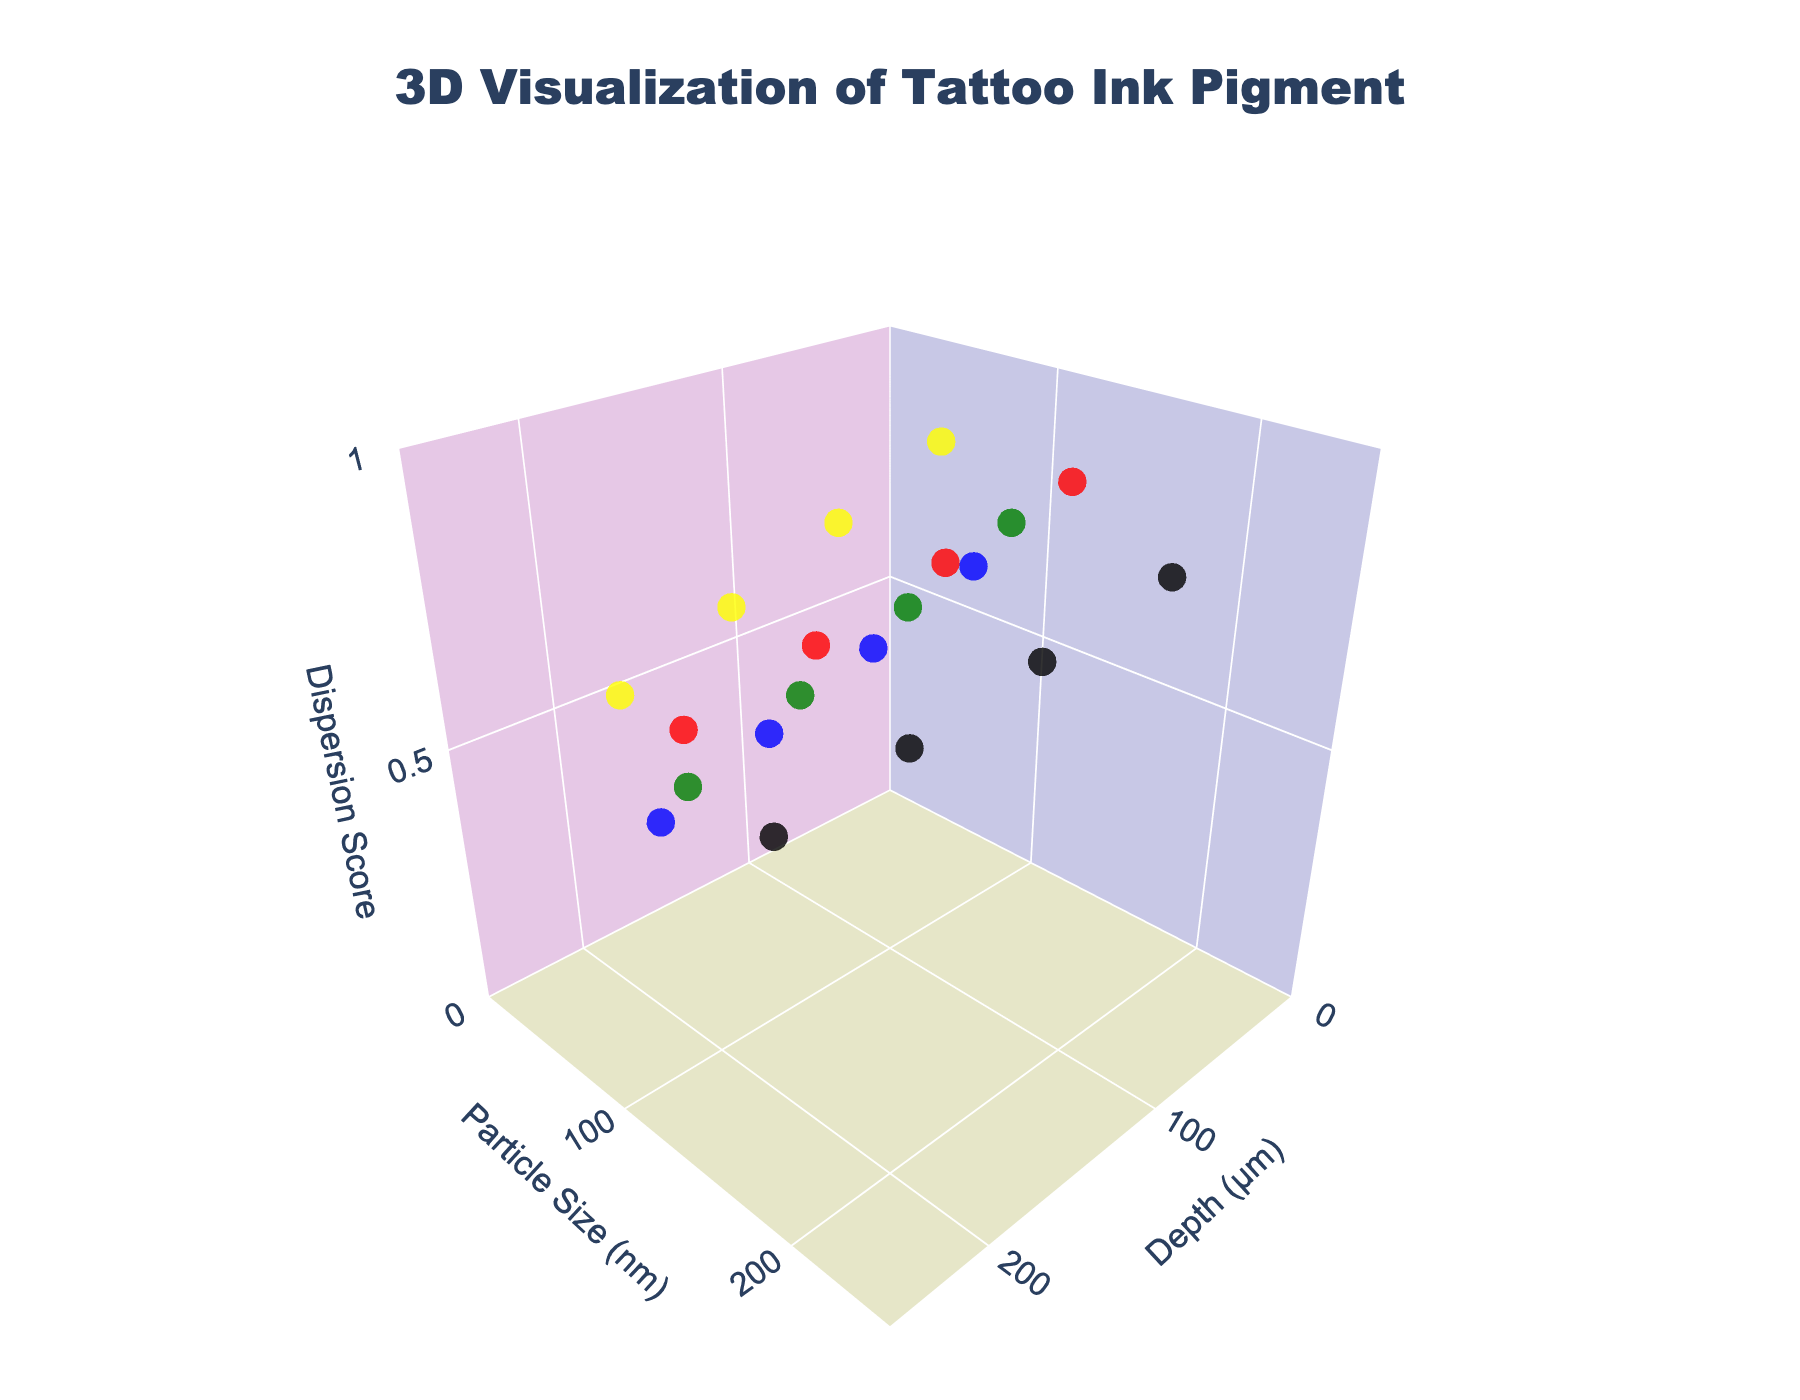What's the title of the figure? The title can be found at the top of the figure. It typically provides an overview of what the figure represents.
Answer: 3D Visualization of Tattoo Ink Pigment What are the labels for the three axes? The axis labels can be found next to each of the three axes in the 3D plot. They indicate what each axis represents.
Answer: Depth (μm), Particle Size (nm), Dispersion Score How many data points are there for each ink color? First, count the number of points for one color, then note the pattern for each subsequent color. Each color appears four times in the plot.
Answer: 4 What's the particle size range for Black ink color? Look for the points in the plot with the 'Black' ink color and read their corresponding particle size values on the y-axis.
Answer: 140-200 nm Which ink color has the highest particle size at 100 μm depth? Examine the plot for points at 100 μm depth and check the particle size value on the y-axis along with their corresponding ink color.
Answer: Black How does the dispersion score for Red ink change with increasing depth? Look at the Red ink points and note the z-axis values, which represent the dispersion score, as the depth (x-axis) increases.
Answer: Decreases from 0.9 to 0.6 Compare the particle sizes of Black and Yellow inks at 50 μm depth. Which is larger? Identify the points at 50 μm depth for both Black and Yellow inks and compare their y-axis values for particle size.
Answer: Black What is the average dispersion score for Blue ink? Identify the dispersion scores for all Blue ink points and calculate their average. Scores are 0.7, 0.6, 0.5, 0.4. Average = (0.7 + 0.6 + 0.5 + 0.4) / 4
Answer: 0.55 Which ink color shows the smallest particle size at 200 μm depth? Examine the points at 200 μm depth and compare their y-axis values for particle size for different colors.
Answer: Yellow What's the general trend in particle size as depth increases for Green ink? Track the points for Green ink and observe how the y-axis values for particle size change as the depth (x-axis) increases.
Answer: Decreases 